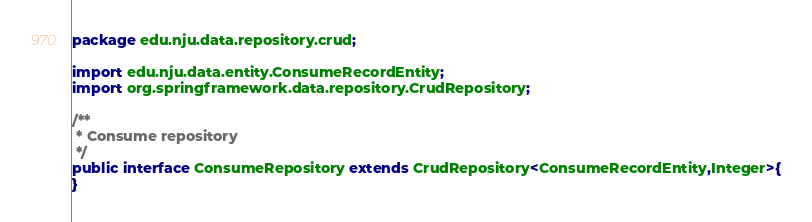<code> <loc_0><loc_0><loc_500><loc_500><_Java_>package edu.nju.data.repository.crud;

import edu.nju.data.entity.ConsumeRecordEntity;
import org.springframework.data.repository.CrudRepository;

/**
 * Consume repository
 */
public interface ConsumeRepository extends CrudRepository<ConsumeRecordEntity,Integer>{
}
</code> 